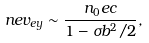Convert formula to latex. <formula><loc_0><loc_0><loc_500><loc_500>n e v _ { e y } \sim \frac { n _ { 0 } e c } { 1 - \sigma b ^ { 2 } / 2 } ,</formula> 